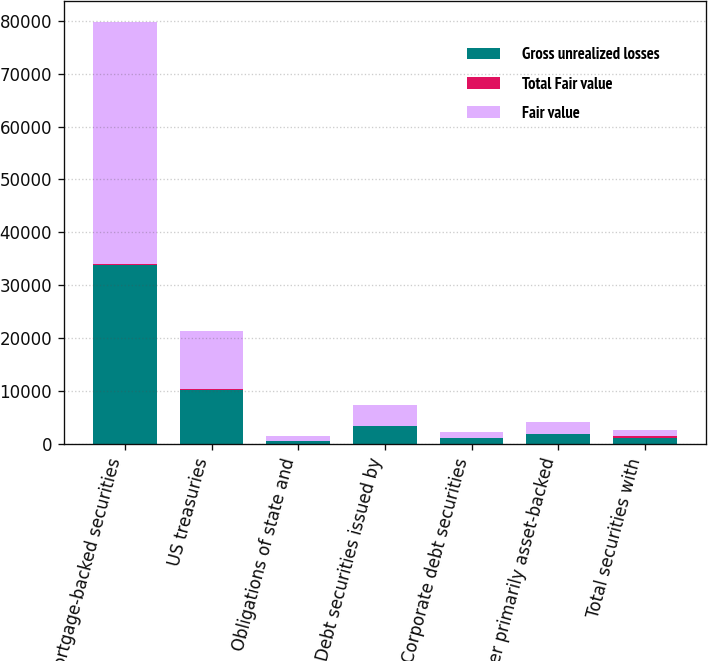Convert chart. <chart><loc_0><loc_0><loc_500><loc_500><stacked_bar_chart><ecel><fcel>Mortgage-backed securities<fcel>US treasuries<fcel>Obligations of state and<fcel>Debt securities issued by<fcel>Corporate debt securities<fcel>Other primarily asset-backed<fcel>Total securities with<nl><fcel>Gross unrealized losses<fcel>33806<fcel>10186<fcel>678<fcel>3395<fcel>1103<fcel>1896<fcel>1103<nl><fcel>Total Fair value<fcel>274<fcel>154<fcel>6<fcel>17<fcel>13<fcel>41<fcel>532<nl><fcel>Fair value<fcel>45690<fcel>11126<fcel>774<fcel>4019<fcel>1228<fcel>2217<fcel>1103<nl></chart> 